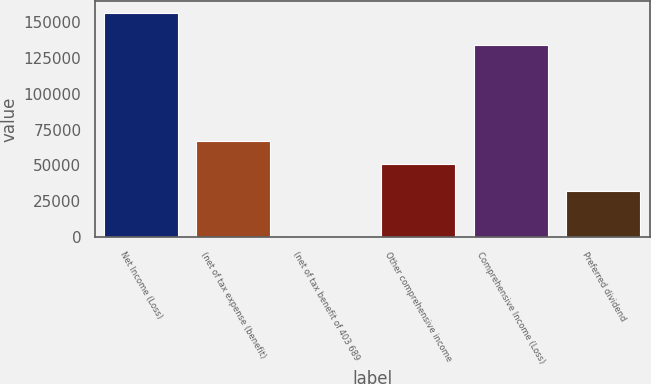Convert chart. <chart><loc_0><loc_0><loc_500><loc_500><bar_chart><fcel>Net Income (Loss)<fcel>(net of tax expense (benefit)<fcel>(net of tax benefit of 403 689<fcel>Other comprehensive income<fcel>Comprehensive Income (Loss)<fcel>Preferred dividend<nl><fcel>156734<fcel>66867.3<fcel>641<fcel>51258<fcel>134404<fcel>31859.6<nl></chart> 